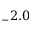<formula> <loc_0><loc_0><loc_500><loc_500>_ { - } 2 . 0</formula> 